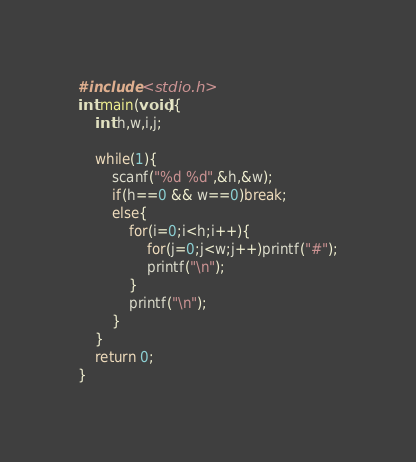Convert code to text. <code><loc_0><loc_0><loc_500><loc_500><_C_>#include <stdio.h>
int main(void){
	int h,w,i,j;

	while(1){
		scanf("%d %d",&h,&w);
		if(h==0 && w==0)break;
		else{
			for(i=0;i<h;i++){
				for(j=0;j<w;j++)printf("#");
				printf("\n");
			}
			printf("\n");
		}
	}
    return 0;
}</code> 